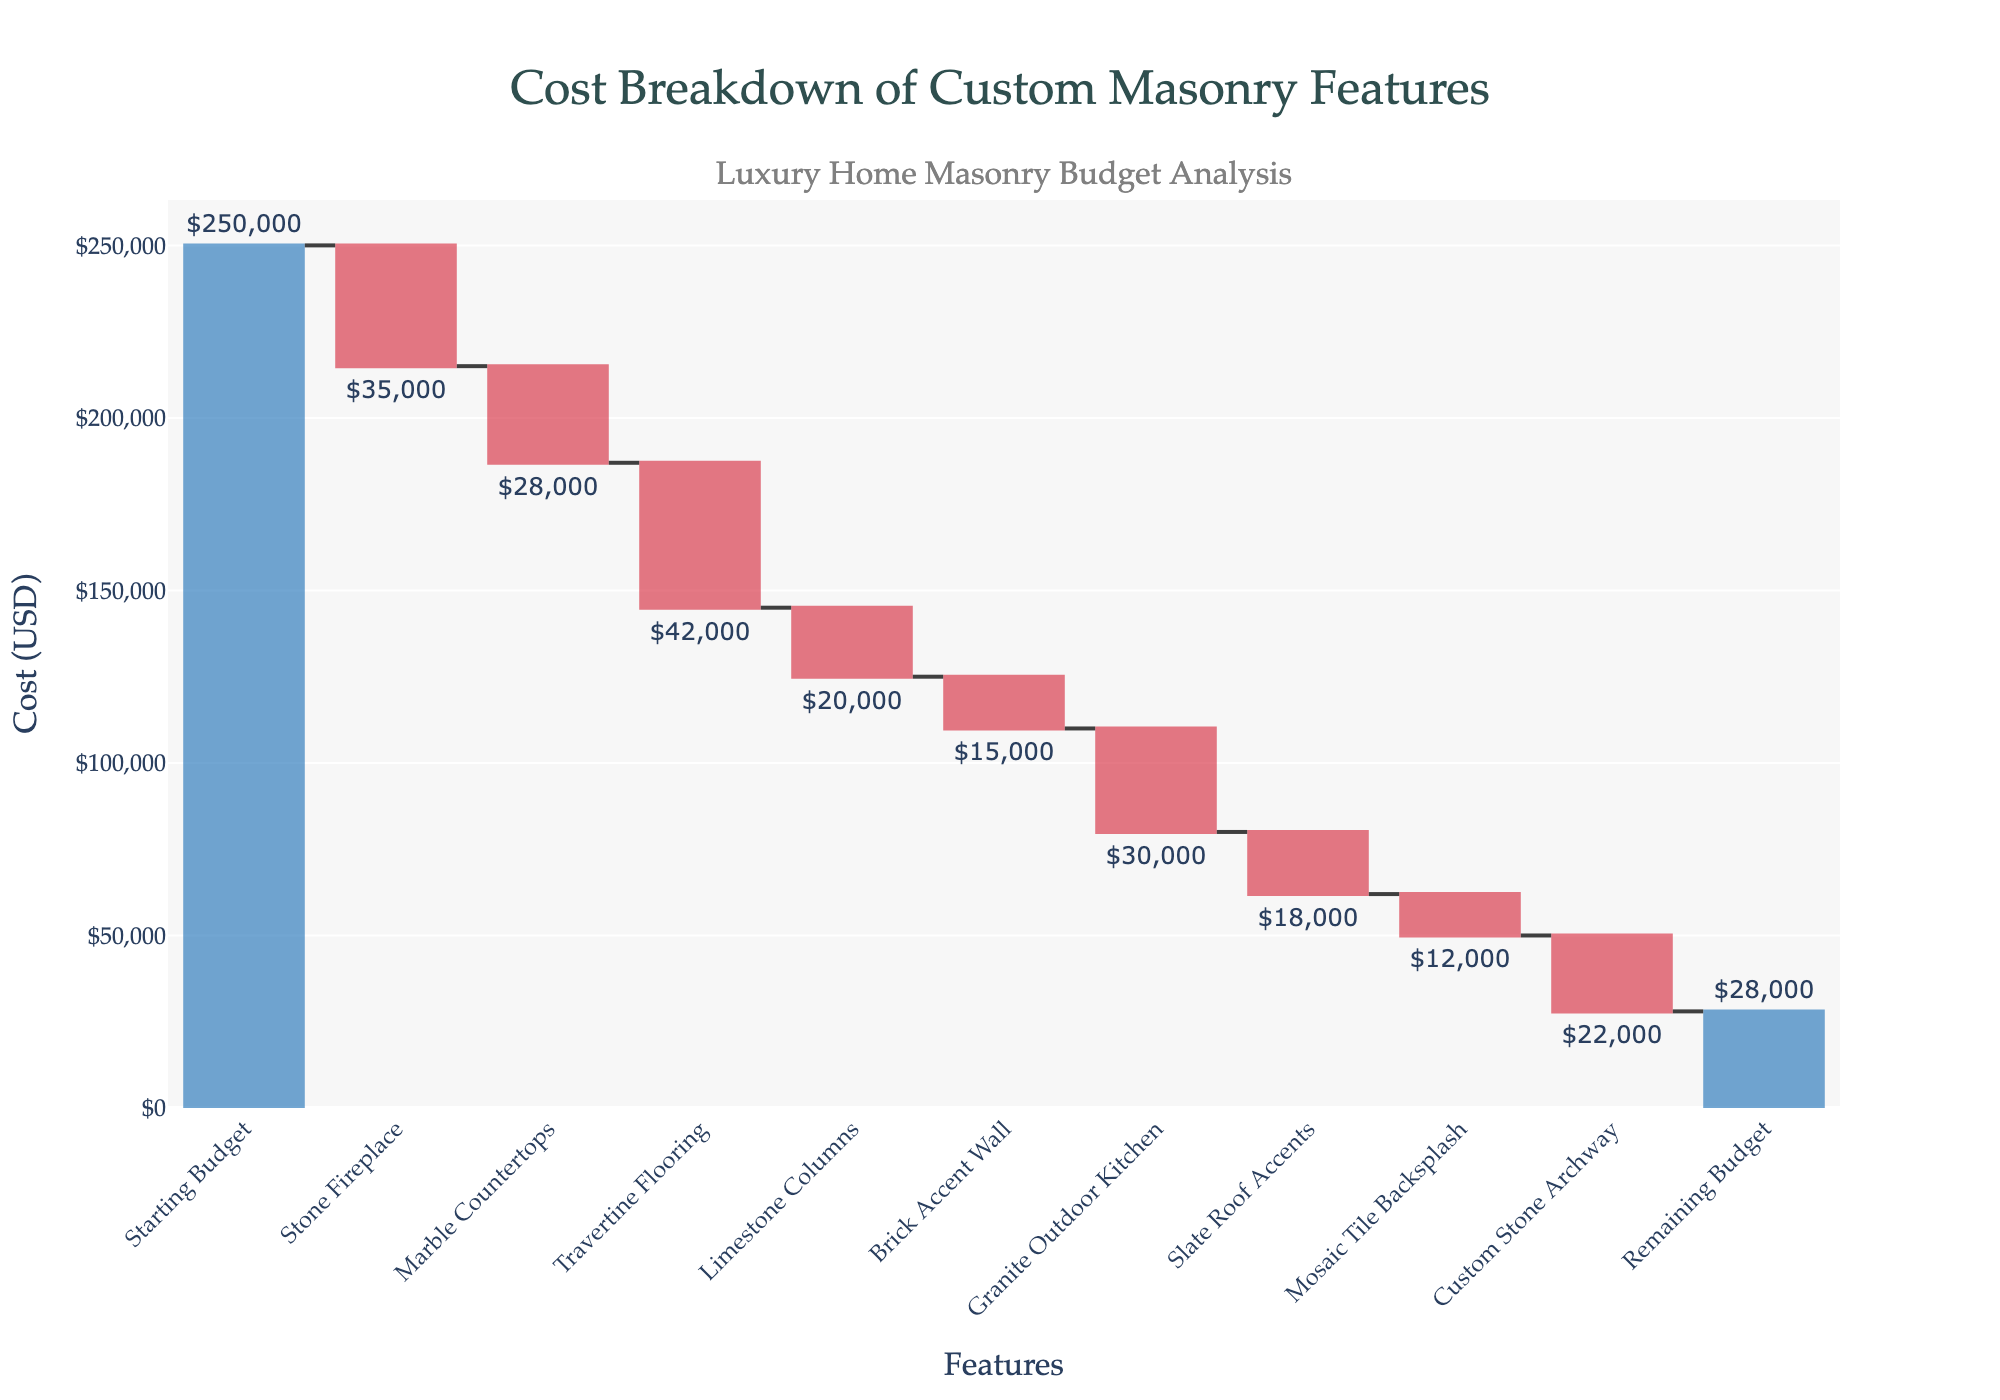What's the title of the chart? The title of the chart is located at the top and reads "Cost Breakdown of Custom Masonry Features".
Answer: Cost Breakdown of Custom Masonry Features How many custom masonry features are included in the budget breakdown? By counting the distinct categories listed along the x-axis excluding the starting and remaining budget, we find there are 9 custom masonry features.
Answer: 9 What was the initial budget? The starting budget is depicted by the first bar in the chart and is labeled "$250,000".
Answer: $250,000 Which custom masonry feature consumed the most budget? By comparing the negative values of each feature, the "Travertine Flooring" bar has the highest negative value, indicating it consumed the most budget.
Answer: Travertine Flooring Which custom masonry feature had the least impact on the budget? The feature with the smallest expenditure is indicated by the smallest negative bar, which is the "Mosaic Tile Backsplash" at $12,000.
Answer: Mosaic Tile Backsplash What's the total cost of all custom masonry features? To find the total cost, sum all the negative values from the custom masonry features: $35,000 (Stone Fireplace) + $28,000 (Marble Countertops) + $42,000 (Travertine Flooring) + $20,000 (Limestone Columns) + $15,000 (Brick Accent Wall) + $30,000 (Granite Outdoor Kitchen) + $18,000 (Slate Roof Accents) + $12,000 (Mosaic Tile Backsplash) + $22,000 (Custom Stone Archway) = $222,000.
Answer: $222,000 What is the remaining budget after accounting for all custom masonry features? The final bar in the chart is labeled "Remaining Budget" with a value of "$28,000".
Answer: $28,000 How does the cost of Stone Fireplace compare to Marble Countertops? The Stone Fireplace cost $35,000, which is $7,000 more than the Marble Countertops, which cost $28,000.
Answer: $7,000 more By how much does the Granite Outdoor Kitchen exceed the cost of the Brick Accent Wall? The cost of the Granite Outdoor Kitchen is $30,000, while the Brick Accent Wall costs $15,000. The difference is $30,000 - $15,000 = $15,000.
Answer: $15,000 What's the average cost per custom masonry feature? The total cost of custom masonry features is $222,000, and there are 9 features. Thus, the average cost is $222,000 / 9 = $24,667.
Answer: $24,667 